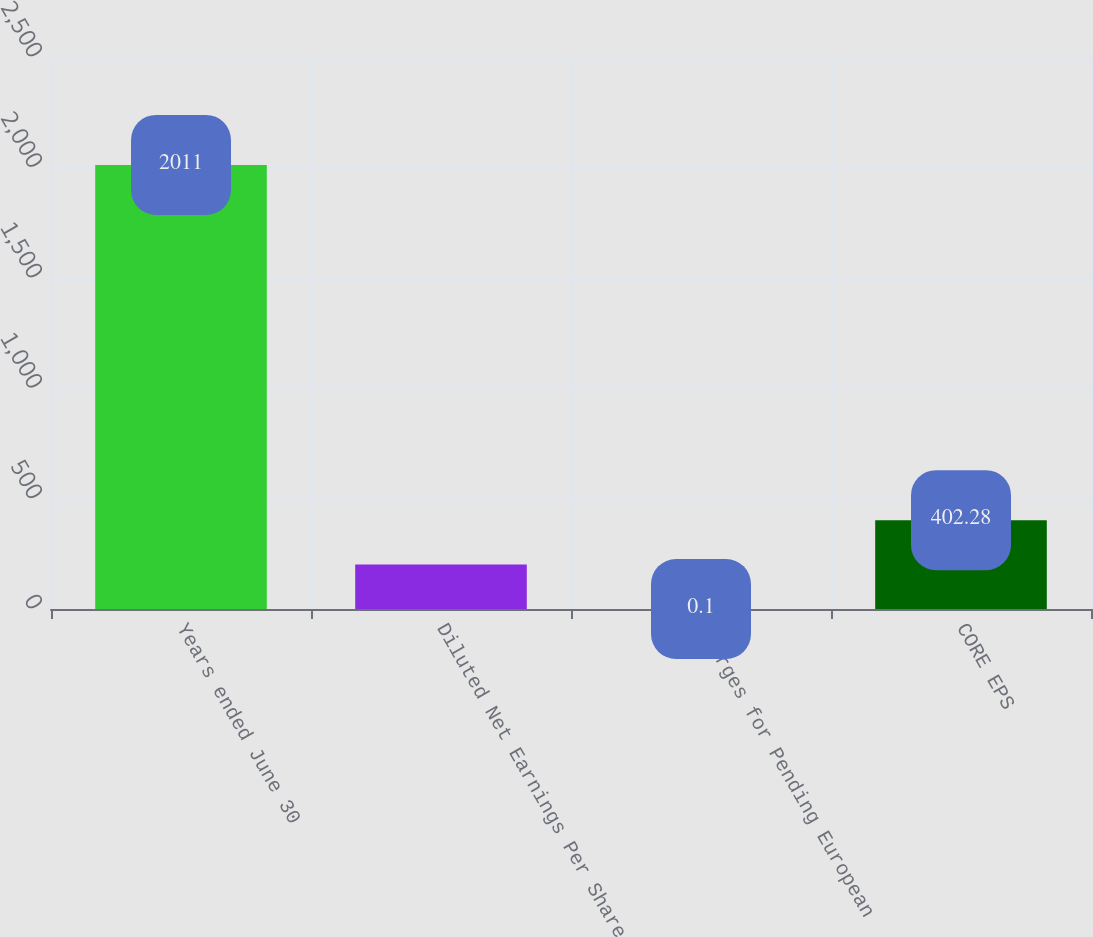<chart> <loc_0><loc_0><loc_500><loc_500><bar_chart><fcel>Years ended June 30<fcel>Diluted Net Earnings Per Share<fcel>Charges for Pending European<fcel>CORE EPS<nl><fcel>2011<fcel>201.19<fcel>0.1<fcel>402.28<nl></chart> 